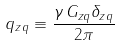Convert formula to latex. <formula><loc_0><loc_0><loc_500><loc_500>q _ { z q } \equiv \frac { \gamma \, G _ { z q } \delta _ { z q } } { 2 \pi }</formula> 